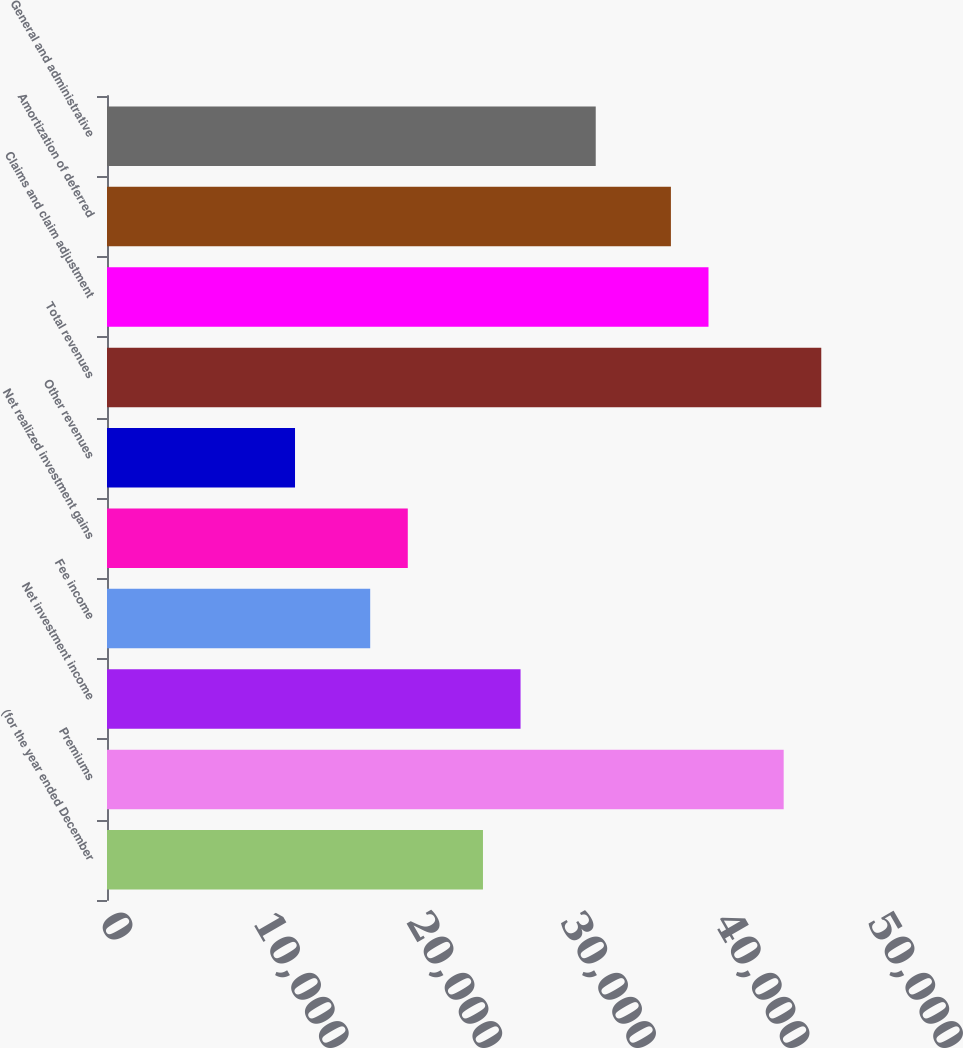Convert chart to OTSL. <chart><loc_0><loc_0><loc_500><loc_500><bar_chart><fcel>(for the year ended December<fcel>Premiums<fcel>Net investment income<fcel>Fee income<fcel>Net realized investment gains<fcel>Other revenues<fcel>Total revenues<fcel>Claims and claim adjustment<fcel>Amortization of deferred<fcel>General and administrative<nl><fcel>24477<fcel>44054.8<fcel>26924.2<fcel>17135.4<fcel>19582.6<fcel>12240.9<fcel>46502<fcel>39160.3<fcel>36713.1<fcel>31818.7<nl></chart> 